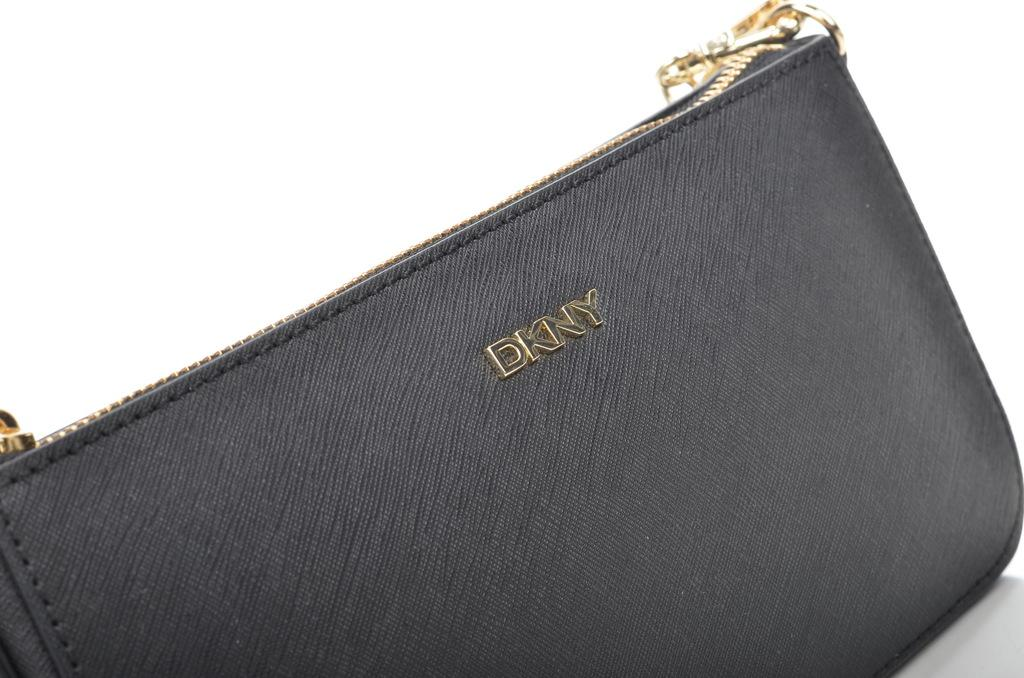What is the color of the bag in the image? The bag in the image is black. What is the color of the zip on the bag? The zip on the bag is golden. What brand name is written on the bag? The brand name "DKNY" is written on the bag. What can be seen in the background of the image? There is a white color wall in the background of the image. What type of magic does the bag perform in the image? There is no magic performed by the bag in the image; it is just a bag with a golden zip and the brand name "DKNY" written on it. 